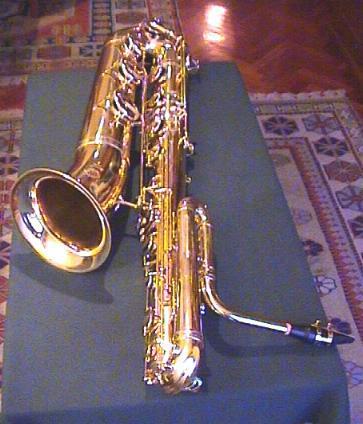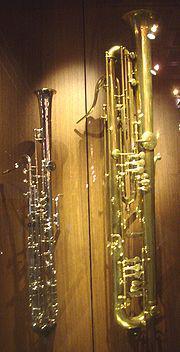The first image is the image on the left, the second image is the image on the right. For the images shown, is this caption "The left image features a saxophone on a stand tilting rightward." true? Answer yes or no. No. 